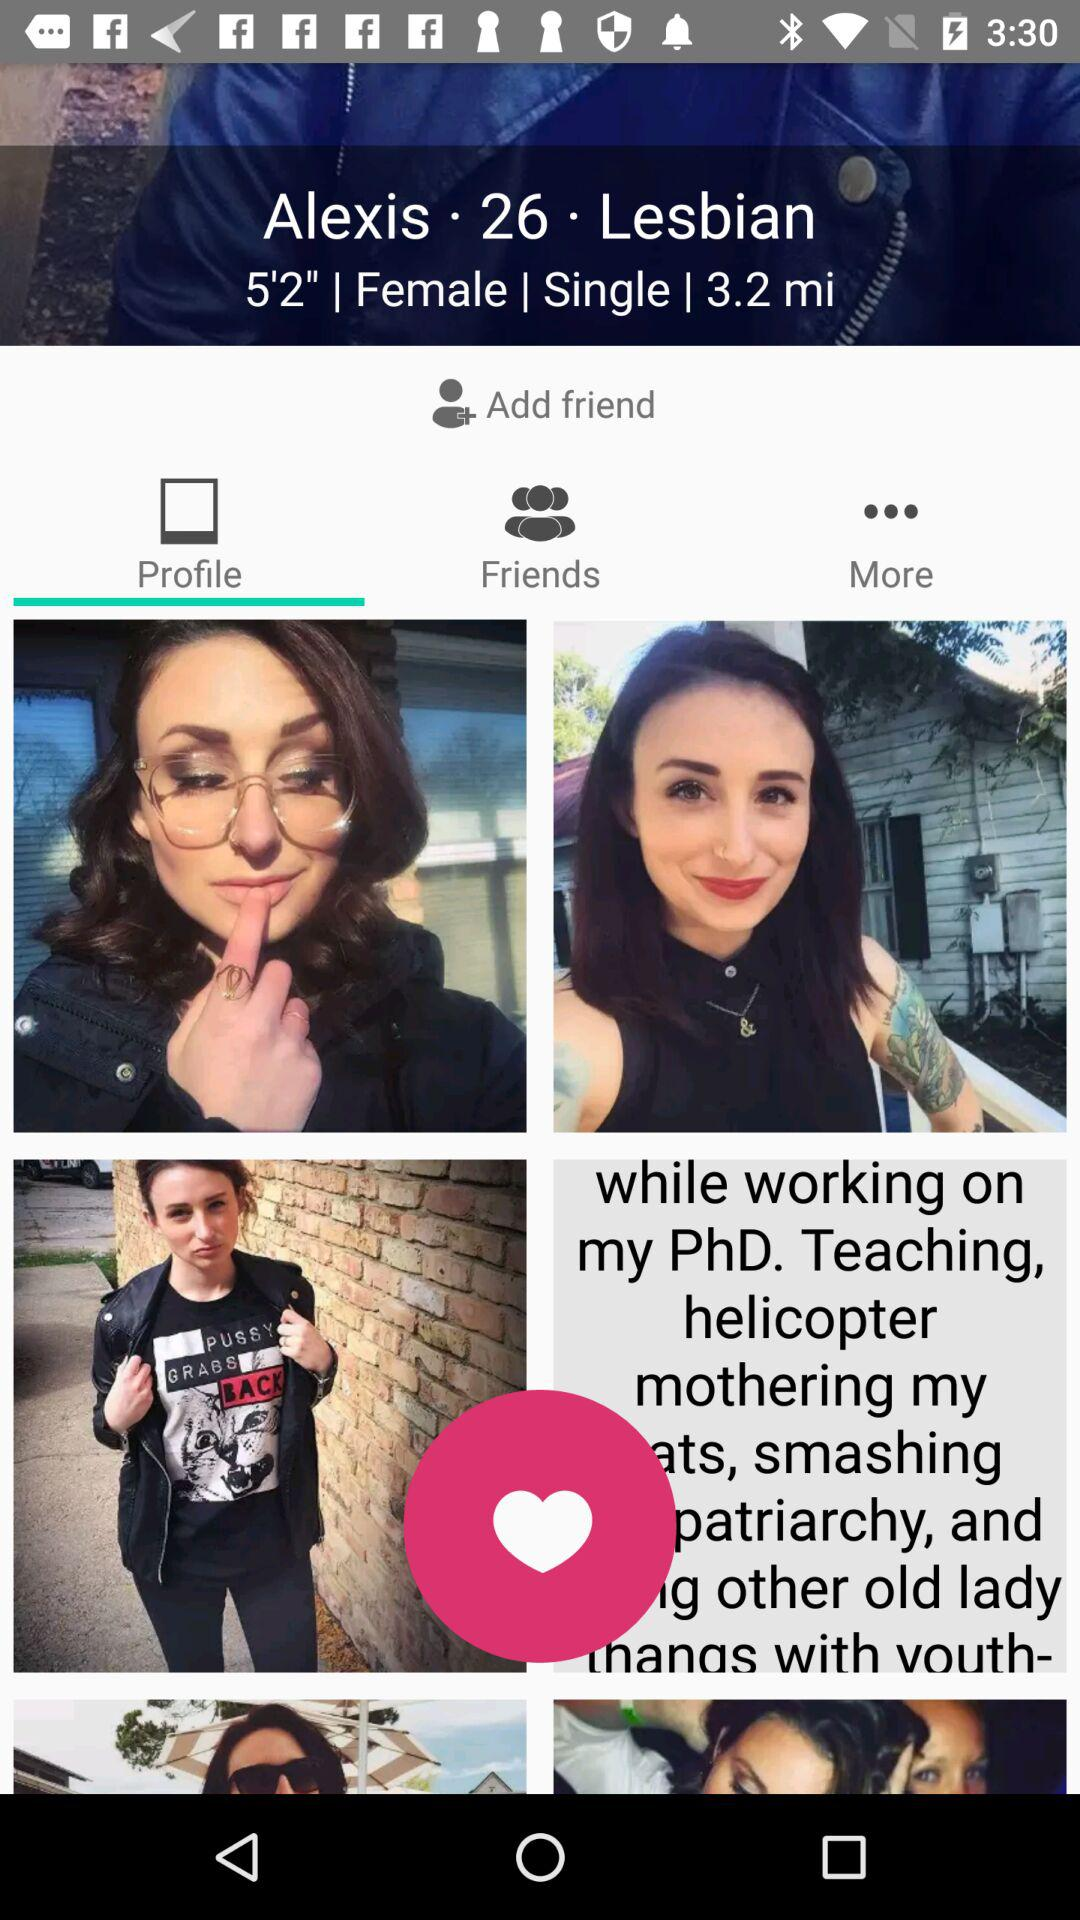Which tab is selected? The selected tab is "Profile". 